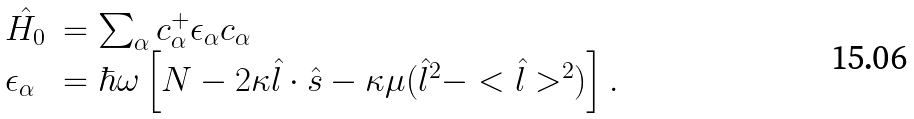Convert formula to latex. <formula><loc_0><loc_0><loc_500><loc_500>\begin{array} { l l } \hat { H _ { 0 } } & = \sum _ { \alpha } c ^ { + } _ { \alpha } \epsilon _ { \alpha } c _ { \alpha } \\ \epsilon _ { \alpha } & = \hbar { \omega } \left [ N - 2 \kappa \hat { l } \cdot \hat { s } - \kappa \mu ( \hat { l } ^ { 2 } - < \hat { l } > ^ { 2 } ) \right ] . \end{array}</formula> 